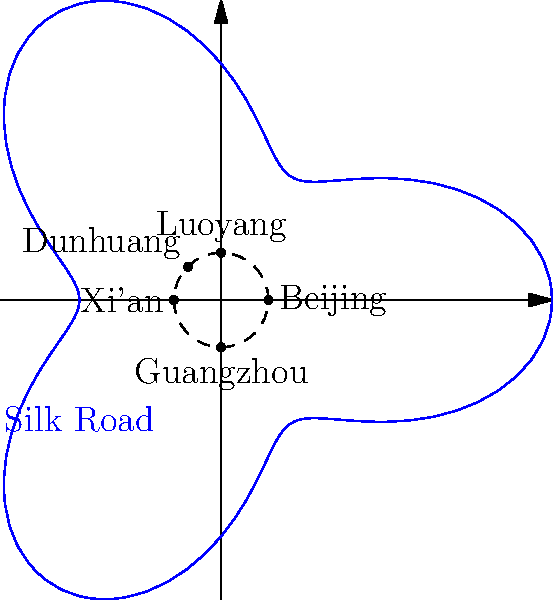In the polar coordinate system representing ancient Chinese trade routes, the Silk Road is modeled by the equation $r = 5 + 2\cos(3\theta)$. If a merchant travels from Beijing to Dunhuang along this route, what is the maximum radial distance they will reach from the origin? To find the maximum radial distance, we need to follow these steps:

1) The equation of the Silk Road is given as $r = 5 + 2\cos(3\theta)$.

2) To find the maximum value of $r$, we need to find the maximum value of $\cos(3\theta)$.

3) We know that the maximum value of cosine is 1, which occurs when its argument is a multiple of $2\pi$.

4) When $\cos(3\theta) = 1$, the equation becomes:
   $r_{max} = 5 + 2(1) = 7$

5) Therefore, the maximum radial distance from the origin is 7 units.

This maximum occurs at several points along the route, representing the farthest reaches of the Silk Road from the central point (origin) in our model.
Answer: 7 units 